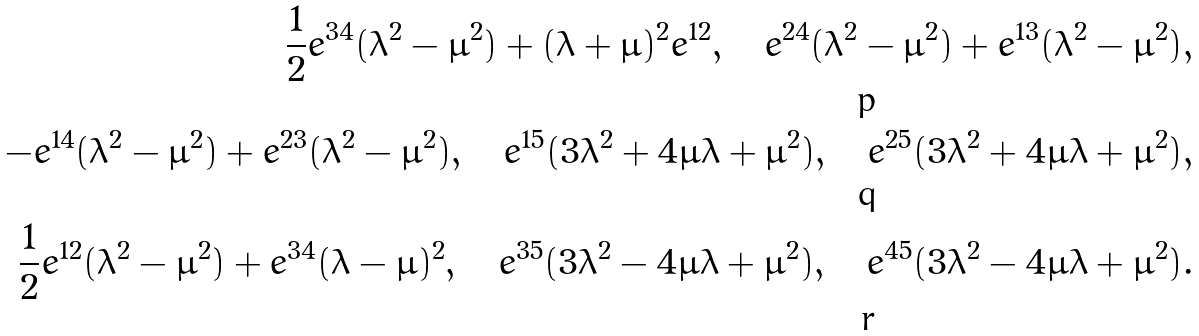Convert formula to latex. <formula><loc_0><loc_0><loc_500><loc_500>\frac { 1 } { 2 } e ^ { 3 4 } { ( \lambda ^ { 2 } - \mu ^ { 2 } ) } + { ( \lambda + \mu ) ^ { 2 } } e ^ { 1 2 } , \quad e ^ { 2 4 } { ( \lambda ^ { 2 } - \mu ^ { 2 } ) } + e ^ { 1 3 } { ( \lambda ^ { 2 } - \mu ^ { 2 } ) } , \\ - e ^ { 1 4 } { ( \lambda ^ { 2 } - \mu ^ { 2 } ) } + e ^ { 2 3 } { ( \lambda ^ { 2 } - \mu ^ { 2 } ) } , \quad e ^ { 1 5 } { ( 3 \lambda ^ { 2 } + 4 \mu \lambda + \mu ^ { 2 } ) } , \quad e ^ { 2 5 } { ( 3 \lambda ^ { 2 } + 4 \mu \lambda + \mu ^ { 2 } ) } , \\ \frac { 1 } { 2 } e ^ { 1 2 } { ( \lambda ^ { 2 } - \mu ^ { 2 } ) } + e ^ { 3 4 } { ( \lambda - \mu ) ^ { 2 } } , \quad e ^ { 3 5 } { ( 3 \lambda ^ { 2 } - 4 \mu \lambda + \mu ^ { 2 } ) } , \quad e ^ { 4 5 } { ( 3 \lambda ^ { 2 } - 4 \mu \lambda + \mu ^ { 2 } ) } .</formula> 